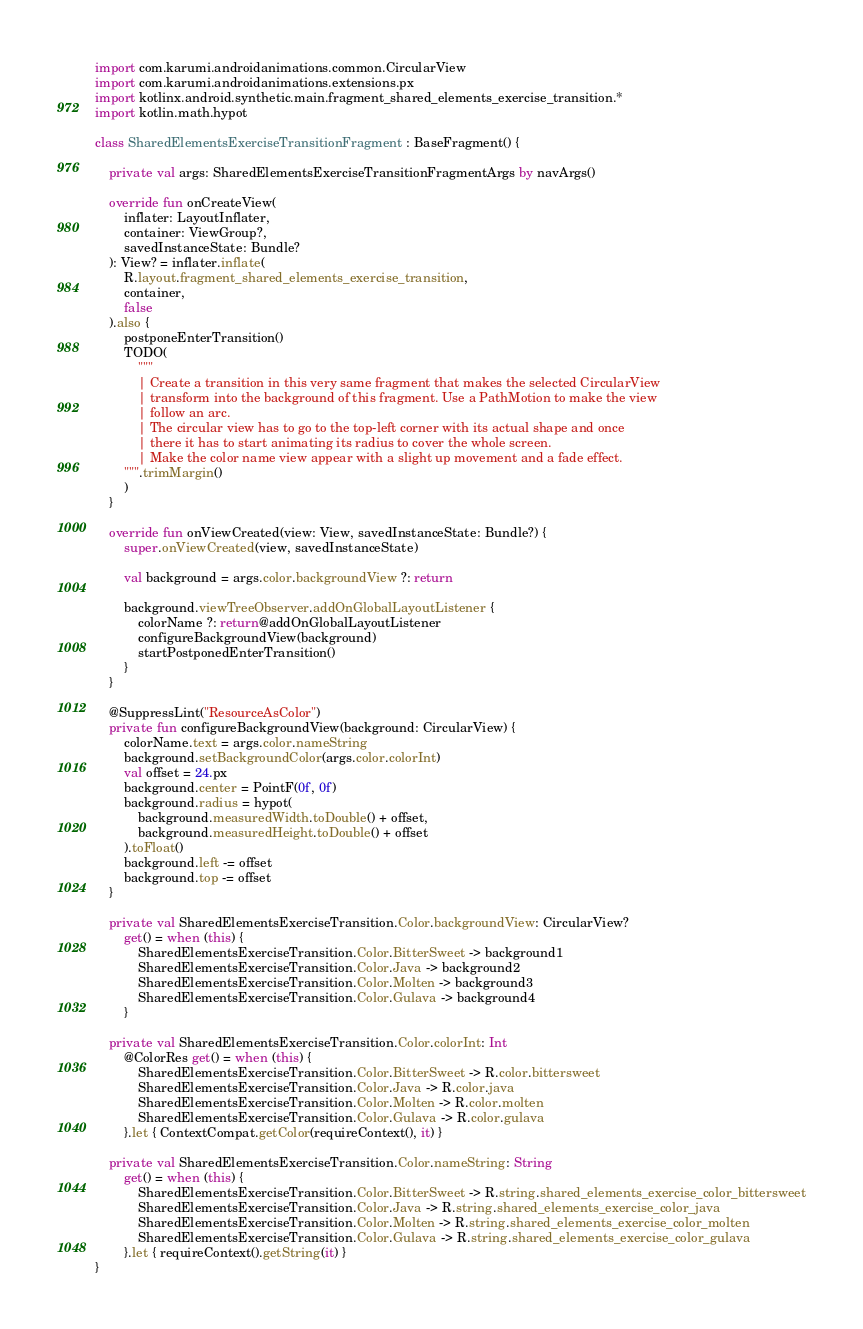<code> <loc_0><loc_0><loc_500><loc_500><_Kotlin_>import com.karumi.androidanimations.common.CircularView
import com.karumi.androidanimations.extensions.px
import kotlinx.android.synthetic.main.fragment_shared_elements_exercise_transition.*
import kotlin.math.hypot

class SharedElementsExerciseTransitionFragment : BaseFragment() {

    private val args: SharedElementsExerciseTransitionFragmentArgs by navArgs()

    override fun onCreateView(
        inflater: LayoutInflater,
        container: ViewGroup?,
        savedInstanceState: Bundle?
    ): View? = inflater.inflate(
        R.layout.fragment_shared_elements_exercise_transition,
        container,
        false
    ).also {
        postponeEnterTransition()
        TODO(
            """
            | Create a transition in this very same fragment that makes the selected CircularView
            | transform into the background of this fragment. Use a PathMotion to make the view
            | follow an arc.
            | The circular view has to go to the top-left corner with its actual shape and once
            | there it has to start animating its radius to cover the whole screen.
            | Make the color name view appear with a slight up movement and a fade effect.
        """.trimMargin()
        )
    }

    override fun onViewCreated(view: View, savedInstanceState: Bundle?) {
        super.onViewCreated(view, savedInstanceState)

        val background = args.color.backgroundView ?: return

        background.viewTreeObserver.addOnGlobalLayoutListener {
            colorName ?: return@addOnGlobalLayoutListener
            configureBackgroundView(background)
            startPostponedEnterTransition()
        }
    }

    @SuppressLint("ResourceAsColor")
    private fun configureBackgroundView(background: CircularView) {
        colorName.text = args.color.nameString
        background.setBackgroundColor(args.color.colorInt)
        val offset = 24.px
        background.center = PointF(0f, 0f)
        background.radius = hypot(
            background.measuredWidth.toDouble() + offset,
            background.measuredHeight.toDouble() + offset
        ).toFloat()
        background.left -= offset
        background.top -= offset
    }

    private val SharedElementsExerciseTransition.Color.backgroundView: CircularView?
        get() = when (this) {
            SharedElementsExerciseTransition.Color.BitterSweet -> background1
            SharedElementsExerciseTransition.Color.Java -> background2
            SharedElementsExerciseTransition.Color.Molten -> background3
            SharedElementsExerciseTransition.Color.Gulava -> background4
        }

    private val SharedElementsExerciseTransition.Color.colorInt: Int
        @ColorRes get() = when (this) {
            SharedElementsExerciseTransition.Color.BitterSweet -> R.color.bittersweet
            SharedElementsExerciseTransition.Color.Java -> R.color.java
            SharedElementsExerciseTransition.Color.Molten -> R.color.molten
            SharedElementsExerciseTransition.Color.Gulava -> R.color.gulava
        }.let { ContextCompat.getColor(requireContext(), it) }

    private val SharedElementsExerciseTransition.Color.nameString: String
        get() = when (this) {
            SharedElementsExerciseTransition.Color.BitterSweet -> R.string.shared_elements_exercise_color_bittersweet
            SharedElementsExerciseTransition.Color.Java -> R.string.shared_elements_exercise_color_java
            SharedElementsExerciseTransition.Color.Molten -> R.string.shared_elements_exercise_color_molten
            SharedElementsExerciseTransition.Color.Gulava -> R.string.shared_elements_exercise_color_gulava
        }.let { requireContext().getString(it) }
}</code> 